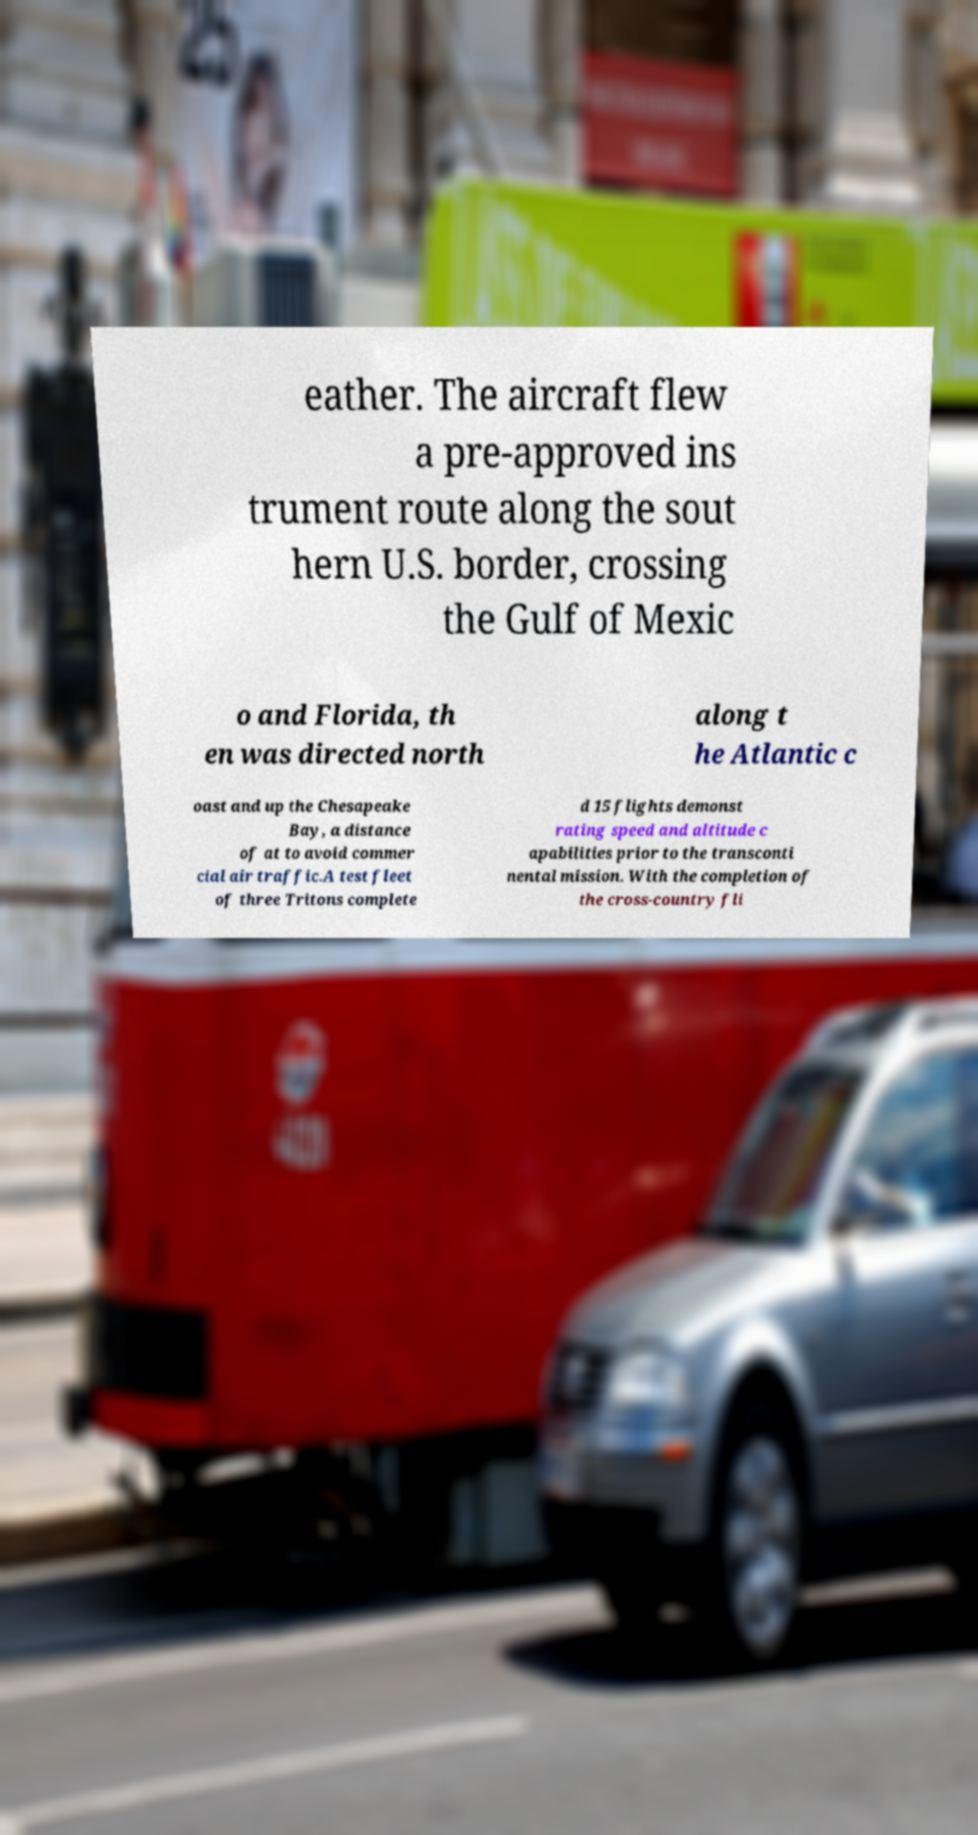Could you assist in decoding the text presented in this image and type it out clearly? eather. The aircraft flew a pre-approved ins trument route along the sout hern U.S. border, crossing the Gulf of Mexic o and Florida, th en was directed north along t he Atlantic c oast and up the Chesapeake Bay, a distance of at to avoid commer cial air traffic.A test fleet of three Tritons complete d 15 flights demonst rating speed and altitude c apabilities prior to the transconti nental mission. With the completion of the cross-country fli 